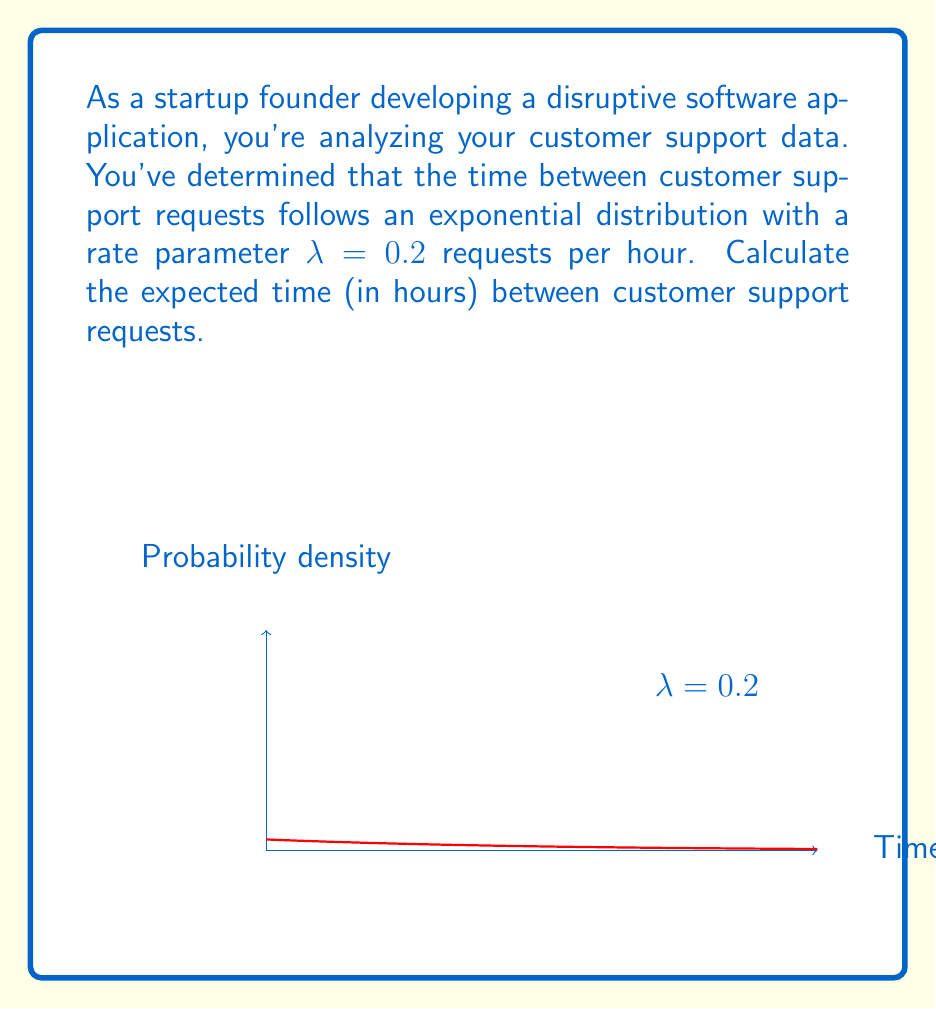Can you solve this math problem? To solve this problem, we'll use the properties of the exponential distribution:

1) The exponential distribution is characterized by its rate parameter λ, which represents the average number of events per unit time.

2) For an exponential distribution, the expected value (mean) is given by:

   $$ E(X) = \frac{1}{\lambda} $$

3) In this case, λ = 0.2 requests per hour.

4) Substituting this value into the formula:

   $$ E(X) = \frac{1}{0.2} = 5 $$

5) Therefore, the expected time between customer support requests is 5 hours.

This result means that, on average, you can expect a customer support request every 5 hours. This information can be valuable for resource allocation and staffing decisions in your startup.
Answer: 5 hours 